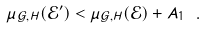<formula> <loc_0><loc_0><loc_500><loc_500>\mu _ { \mathcal { G } , H } ( \mathcal { E } ^ { \prime } ) < \mu _ { \mathcal { G } , H } ( \mathcal { E } ) + A _ { 1 } \ .</formula> 